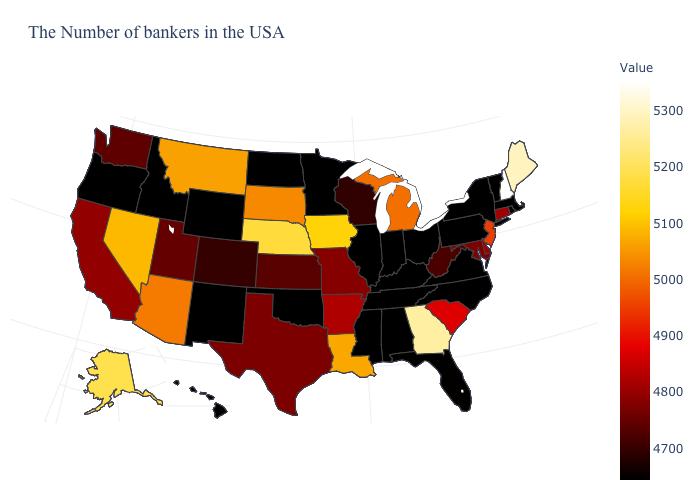Does Texas have a lower value than South Carolina?
Answer briefly. Yes. 